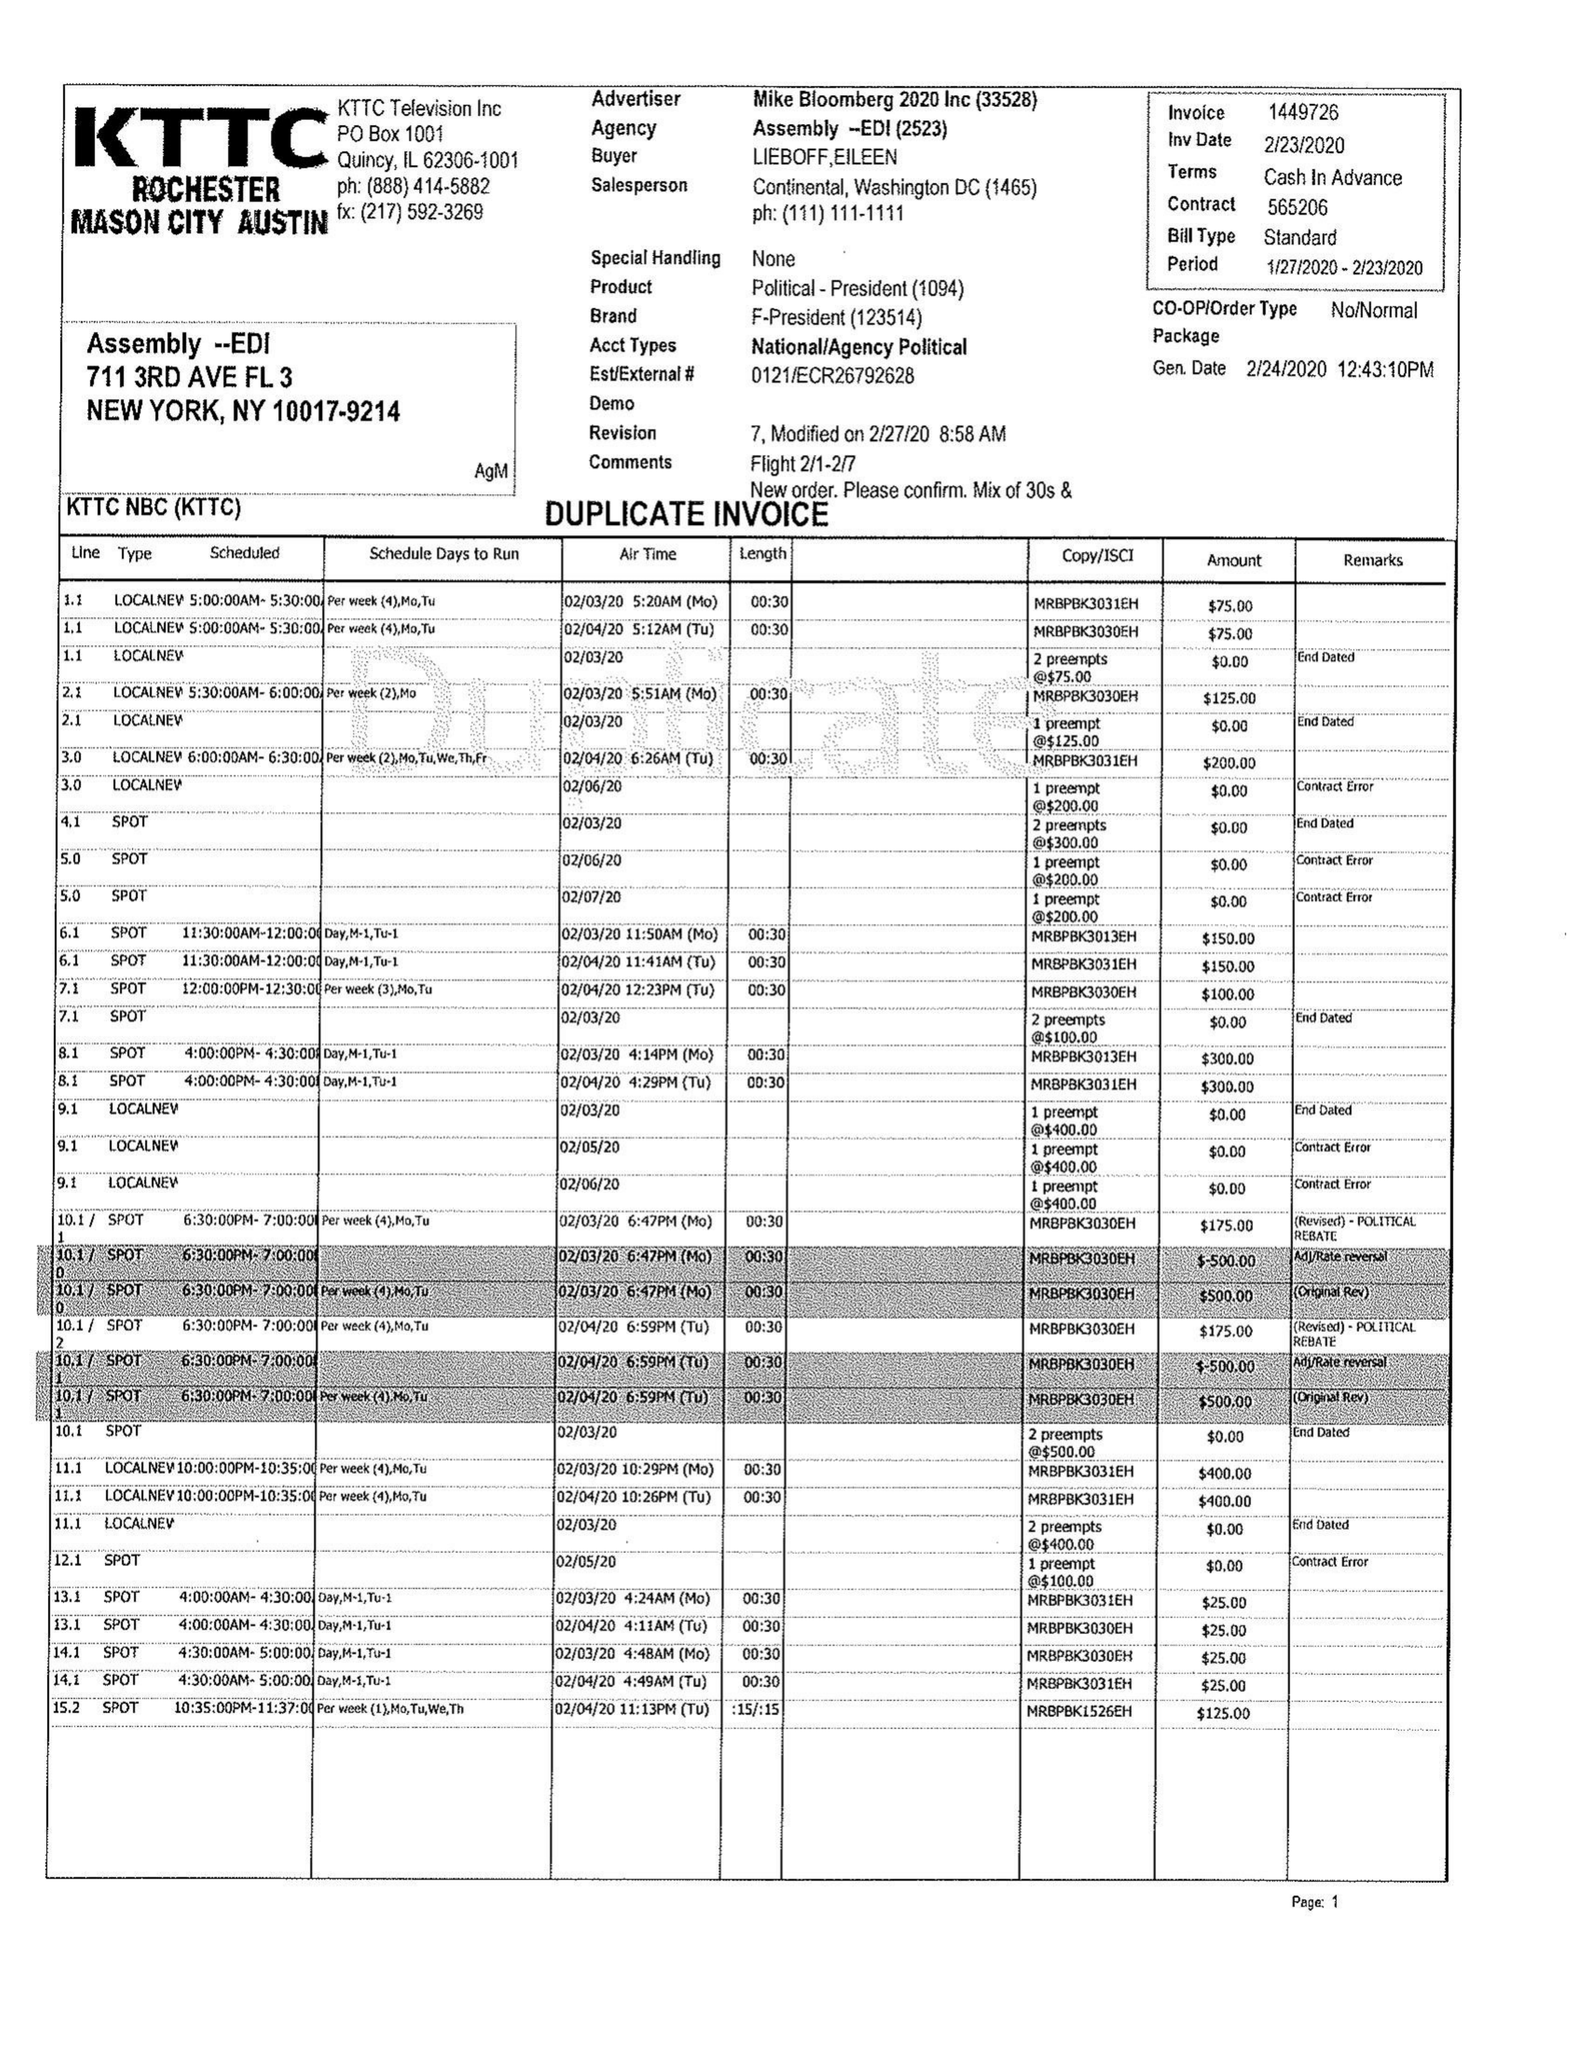What is the value for the flight_to?
Answer the question using a single word or phrase. 02/23/20 